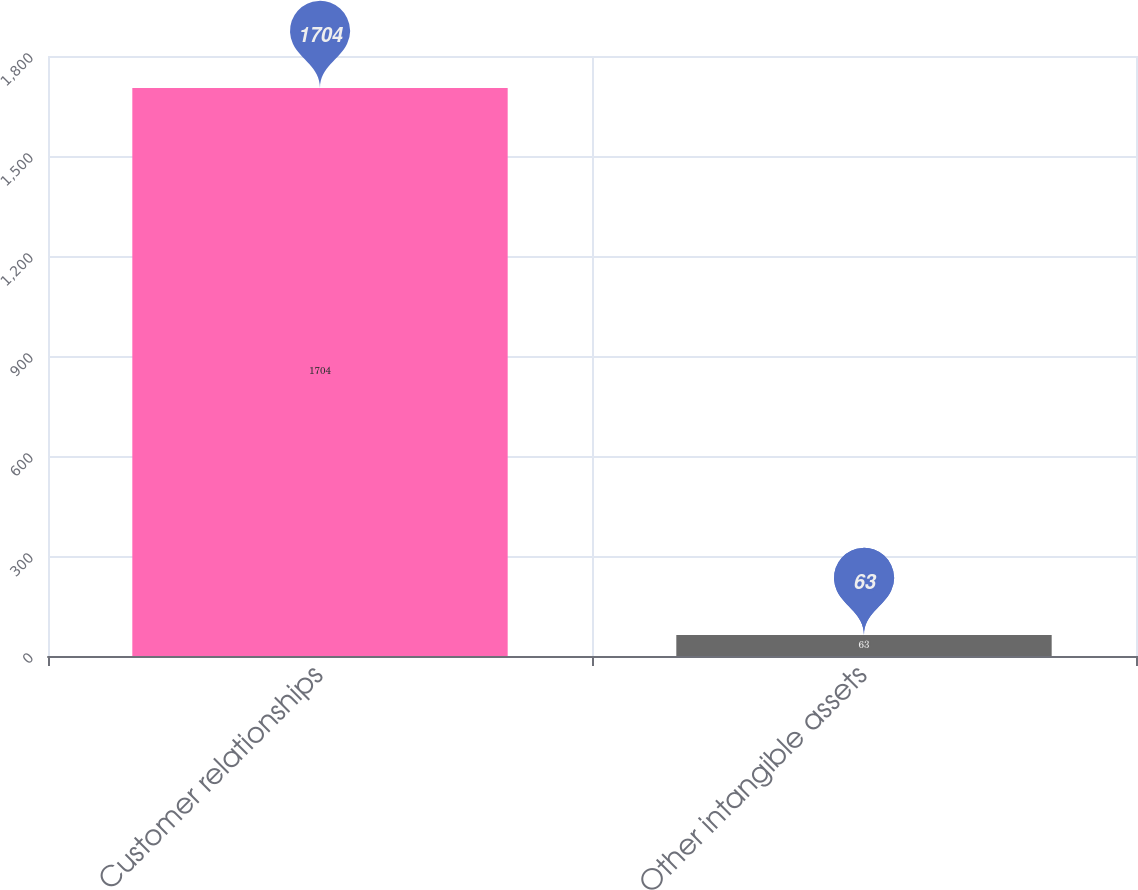<chart> <loc_0><loc_0><loc_500><loc_500><bar_chart><fcel>Customer relationships<fcel>Other intangible assets<nl><fcel>1704<fcel>63<nl></chart> 